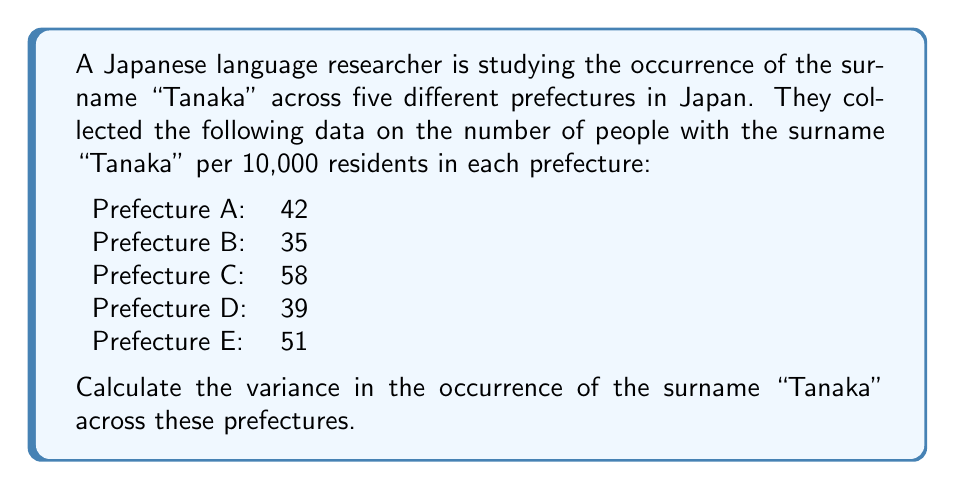Teach me how to tackle this problem. To calculate the variance, we'll follow these steps:

1. Calculate the mean ($\mu$) of the data:
   $$\mu = \frac{42 + 35 + 58 + 39 + 51}{5} = 45$$

2. Calculate the squared differences from the mean:
   Prefecture A: $(42 - 45)^2 = (-3)^2 = 9$
   Prefecture B: $(35 - 45)^2 = (-10)^2 = 100$
   Prefecture C: $(58 - 45)^2 = (13)^2 = 169$
   Prefecture D: $(39 - 45)^2 = (-6)^2 = 36$
   Prefecture E: $(51 - 45)^2 = (6)^2 = 36$

3. Sum the squared differences:
   $$9 + 100 + 169 + 36 + 36 = 350$$

4. Divide by the number of prefectures (n = 5) to get the variance:
   $$\text{Variance} = \frac{\sum (x_i - \mu)^2}{n} = \frac{350}{5} = 70$$

The formula for variance is:

$$\sigma^2 = \frac{\sum_{i=1}^{n} (x_i - \mu)^2}{n}$$

Where:
$\sigma^2$ is the variance
$x_i$ are the individual values
$\mu$ is the mean
$n$ is the number of values
Answer: The variance in the occurrence of the surname "Tanaka" across the five prefectures is 70 (per 10,000 residents squared). 